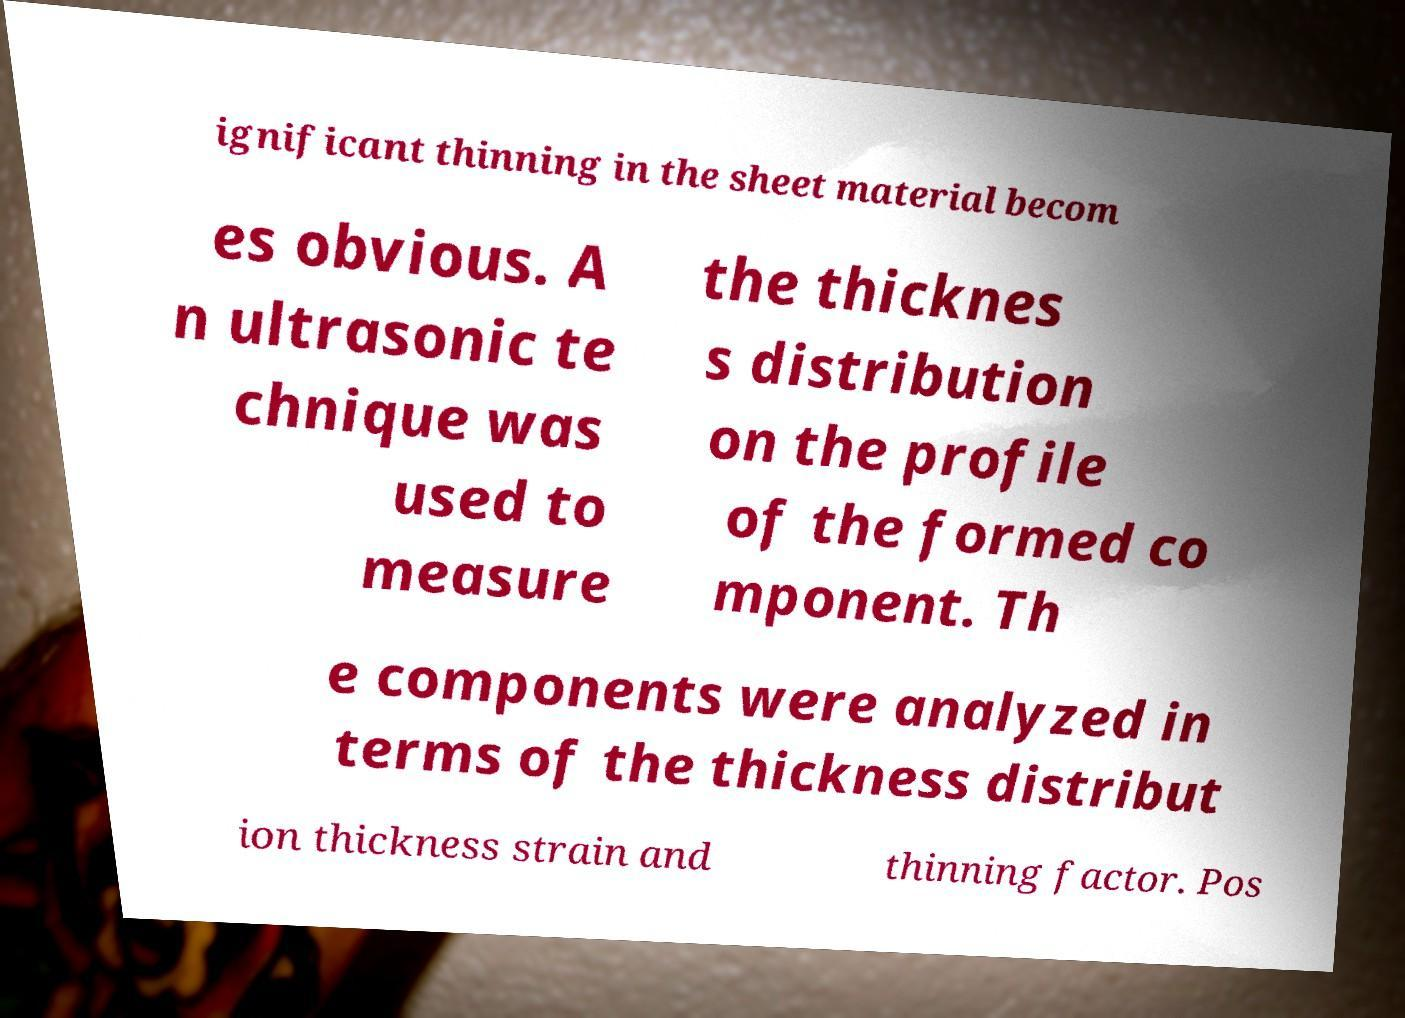Can you accurately transcribe the text from the provided image for me? ignificant thinning in the sheet material becom es obvious. A n ultrasonic te chnique was used to measure the thicknes s distribution on the profile of the formed co mponent. Th e components were analyzed in terms of the thickness distribut ion thickness strain and thinning factor. Pos 